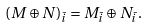<formula> <loc_0><loc_0><loc_500><loc_500>( M \oplus N ) _ { \bar { i } } = M _ { \bar { i } } \oplus N _ { \bar { i } } .</formula> 